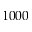<formula> <loc_0><loc_0><loc_500><loc_500>1 0 0 0</formula> 